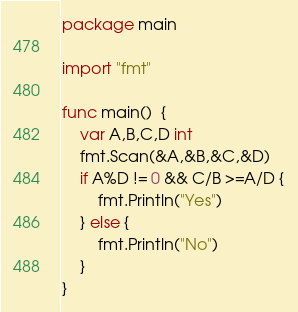Convert code to text. <code><loc_0><loc_0><loc_500><loc_500><_Go_>package main

import "fmt"

func main()  {
	var A,B,C,D int
	fmt.Scan(&A,&B,&C,&D)
	if A%D != 0 && C/B >=A/D {
		fmt.Println("Yes")
	} else {
		fmt.Println("No")
	}
}</code> 